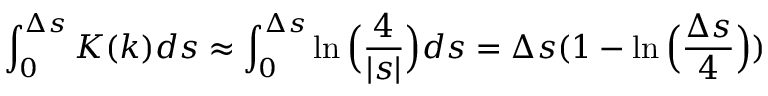<formula> <loc_0><loc_0><loc_500><loc_500>\int _ { 0 } ^ { \Delta s } K ( k ) d s \approx \int _ { 0 } ^ { \Delta s } \ln \left ( \frac { 4 } { | s | } \right ) d s = \Delta s ( 1 - \ln \left ( { \frac { \Delta s } { 4 } } \right ) )</formula> 